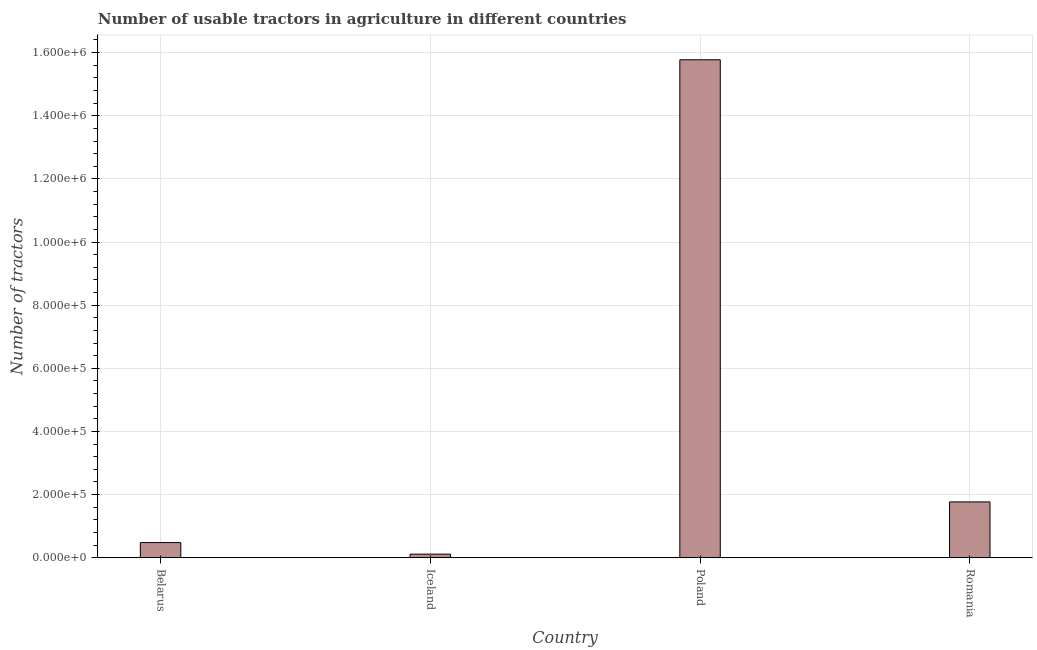Does the graph contain grids?
Keep it short and to the point. Yes. What is the title of the graph?
Your response must be concise. Number of usable tractors in agriculture in different countries. What is the label or title of the Y-axis?
Ensure brevity in your answer.  Number of tractors. What is the number of tractors in Belarus?
Provide a short and direct response. 4.81e+04. Across all countries, what is the maximum number of tractors?
Provide a succinct answer. 1.58e+06. Across all countries, what is the minimum number of tractors?
Ensure brevity in your answer.  1.14e+04. In which country was the number of tractors maximum?
Give a very brief answer. Poland. What is the sum of the number of tractors?
Make the answer very short. 1.81e+06. What is the difference between the number of tractors in Iceland and Poland?
Provide a succinct answer. -1.57e+06. What is the average number of tractors per country?
Make the answer very short. 4.53e+05. What is the median number of tractors?
Your answer should be very brief. 1.12e+05. In how many countries, is the number of tractors greater than 1560000 ?
Give a very brief answer. 1. Is the difference between the number of tractors in Poland and Romania greater than the difference between any two countries?
Offer a terse response. No. What is the difference between the highest and the second highest number of tractors?
Ensure brevity in your answer.  1.40e+06. Is the sum of the number of tractors in Poland and Romania greater than the maximum number of tractors across all countries?
Provide a succinct answer. Yes. What is the difference between the highest and the lowest number of tractors?
Your answer should be very brief. 1.57e+06. How many bars are there?
Ensure brevity in your answer.  4. How many countries are there in the graph?
Keep it short and to the point. 4. What is the difference between two consecutive major ticks on the Y-axis?
Keep it short and to the point. 2.00e+05. Are the values on the major ticks of Y-axis written in scientific E-notation?
Offer a terse response. Yes. What is the Number of tractors of Belarus?
Make the answer very short. 4.81e+04. What is the Number of tractors of Iceland?
Your answer should be compact. 1.14e+04. What is the Number of tractors in Poland?
Offer a terse response. 1.58e+06. What is the Number of tractors in Romania?
Offer a very short reply. 1.77e+05. What is the difference between the Number of tractors in Belarus and Iceland?
Make the answer very short. 3.67e+04. What is the difference between the Number of tractors in Belarus and Poland?
Provide a short and direct response. -1.53e+06. What is the difference between the Number of tractors in Belarus and Romania?
Your response must be concise. -1.29e+05. What is the difference between the Number of tractors in Iceland and Poland?
Offer a terse response. -1.57e+06. What is the difference between the Number of tractors in Iceland and Romania?
Your answer should be compact. -1.65e+05. What is the difference between the Number of tractors in Poland and Romania?
Give a very brief answer. 1.40e+06. What is the ratio of the Number of tractors in Belarus to that in Iceland?
Keep it short and to the point. 4.21. What is the ratio of the Number of tractors in Belarus to that in Romania?
Your answer should be very brief. 0.27. What is the ratio of the Number of tractors in Iceland to that in Poland?
Provide a succinct answer. 0.01. What is the ratio of the Number of tractors in Iceland to that in Romania?
Your answer should be compact. 0.07. What is the ratio of the Number of tractors in Poland to that in Romania?
Your answer should be very brief. 8.92. 